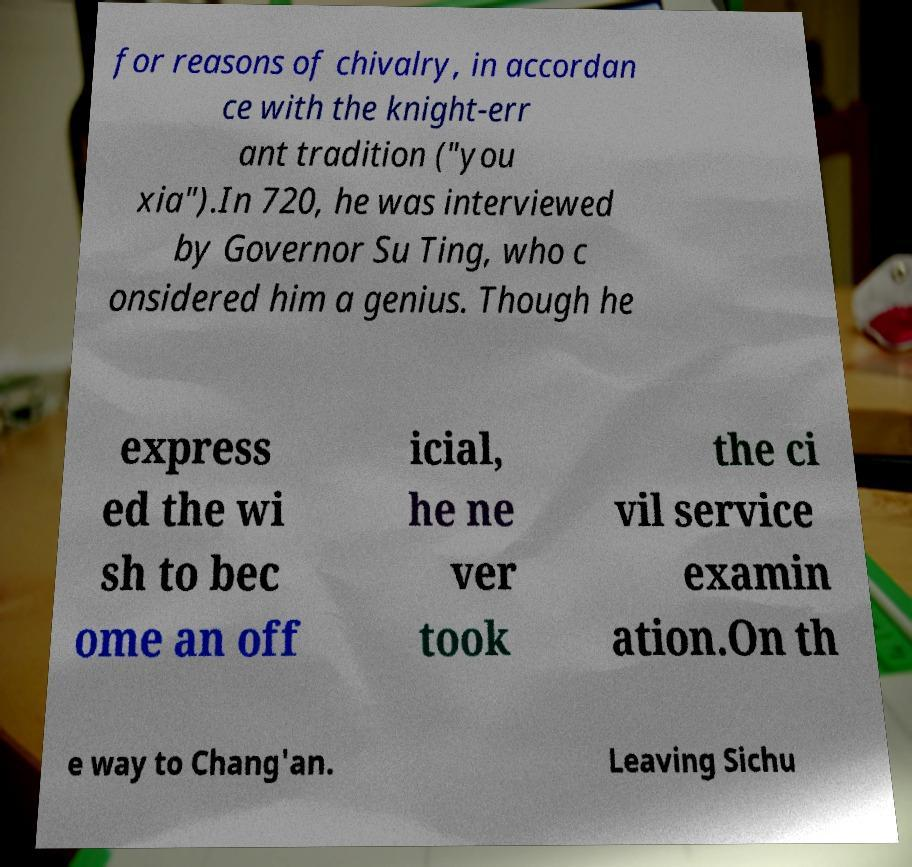Can you accurately transcribe the text from the provided image for me? for reasons of chivalry, in accordan ce with the knight-err ant tradition ("you xia").In 720, he was interviewed by Governor Su Ting, who c onsidered him a genius. Though he express ed the wi sh to bec ome an off icial, he ne ver took the ci vil service examin ation.On th e way to Chang'an. Leaving Sichu 